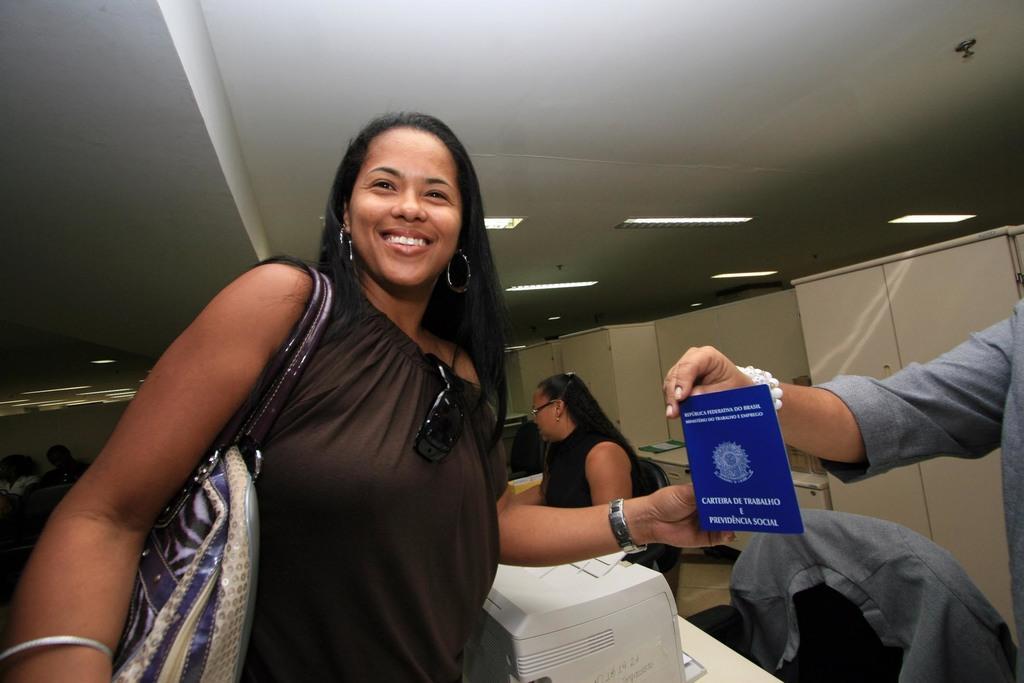Please provide a concise description of this image. In this picture we can see a woman standing and holding something, in the background there is a woman sitting on the chair, we can see a cloth here, there are some lights and ceiling at the top of the picture, this woman is carrying a handbag. 